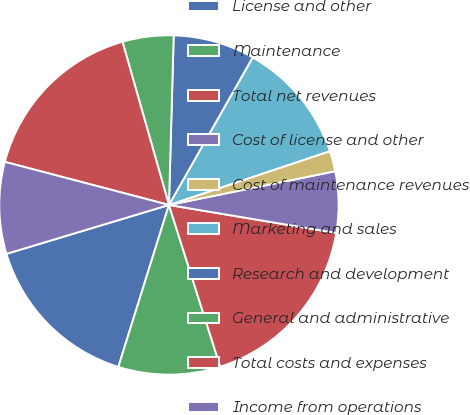<chart> <loc_0><loc_0><loc_500><loc_500><pie_chart><fcel>License and other<fcel>Maintenance<fcel>Total net revenues<fcel>Cost of license and other<fcel>Cost of maintenance revenues<fcel>Marketing and sales<fcel>Research and development<fcel>General and administrative<fcel>Total costs and expenses<fcel>Income from operations<nl><fcel>15.53%<fcel>9.71%<fcel>17.47%<fcel>5.83%<fcel>1.95%<fcel>11.65%<fcel>7.77%<fcel>4.86%<fcel>16.5%<fcel>8.74%<nl></chart> 